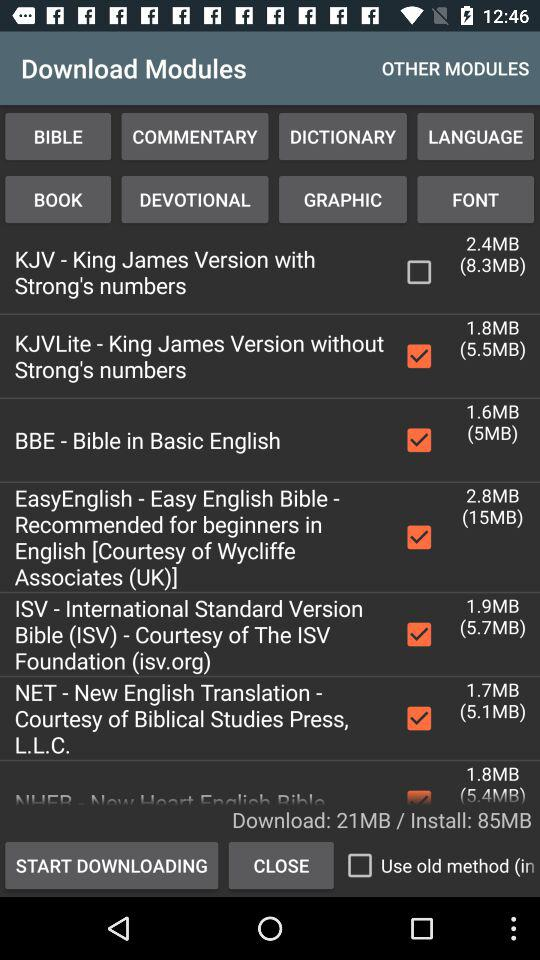How much data is downloaded in MB? The data downloaded is 21 MB. 